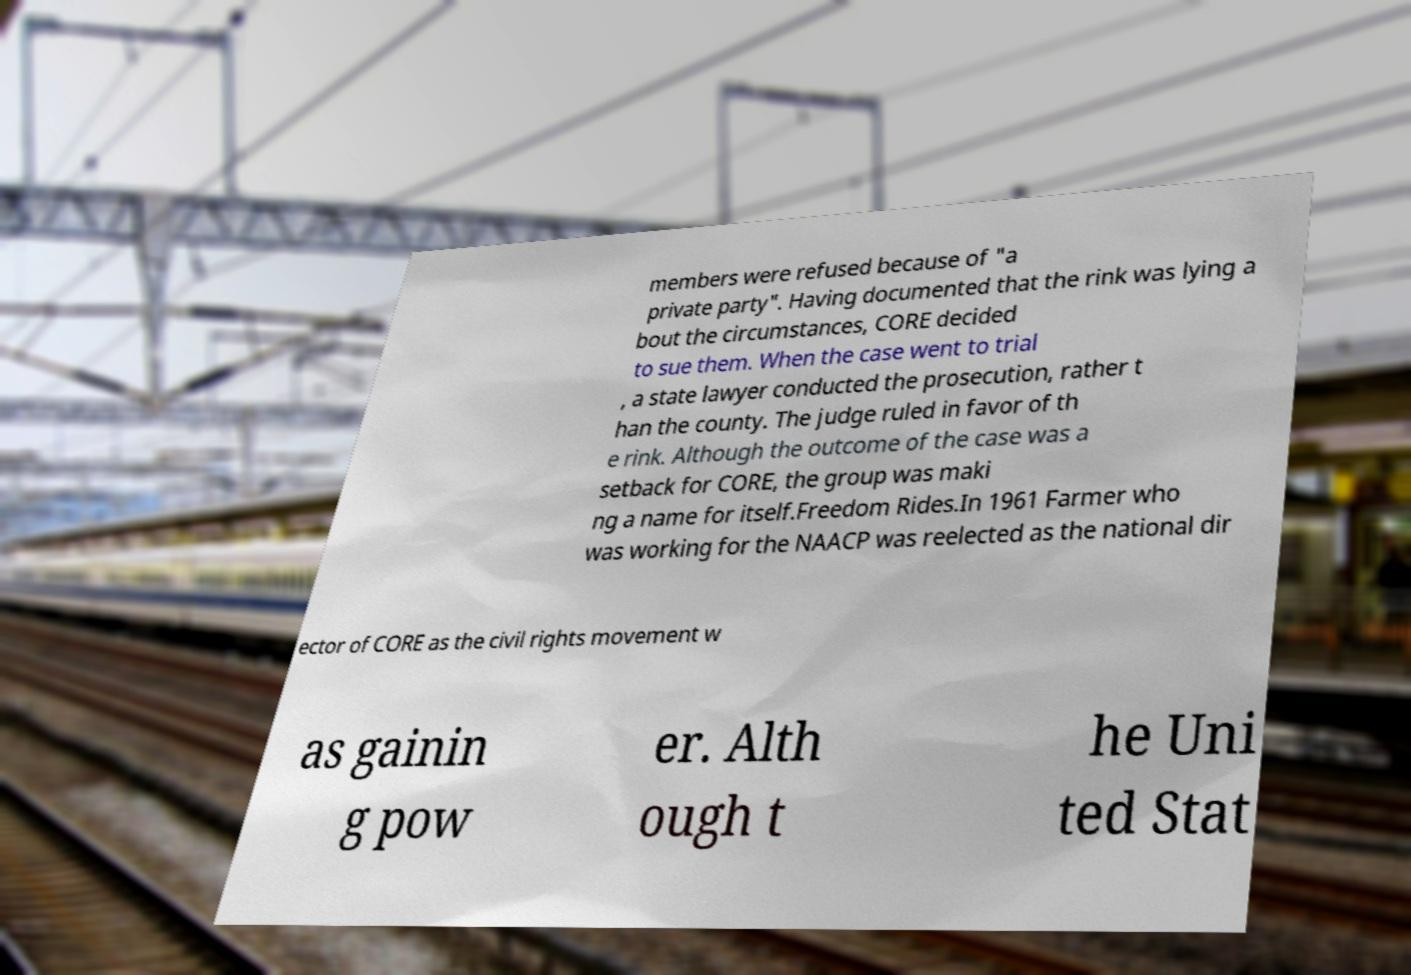Could you extract and type out the text from this image? members were refused because of "a private party". Having documented that the rink was lying a bout the circumstances, CORE decided to sue them. When the case went to trial , a state lawyer conducted the prosecution, rather t han the county. The judge ruled in favor of th e rink. Although the outcome of the case was a setback for CORE, the group was maki ng a name for itself.Freedom Rides.In 1961 Farmer who was working for the NAACP was reelected as the national dir ector of CORE as the civil rights movement w as gainin g pow er. Alth ough t he Uni ted Stat 